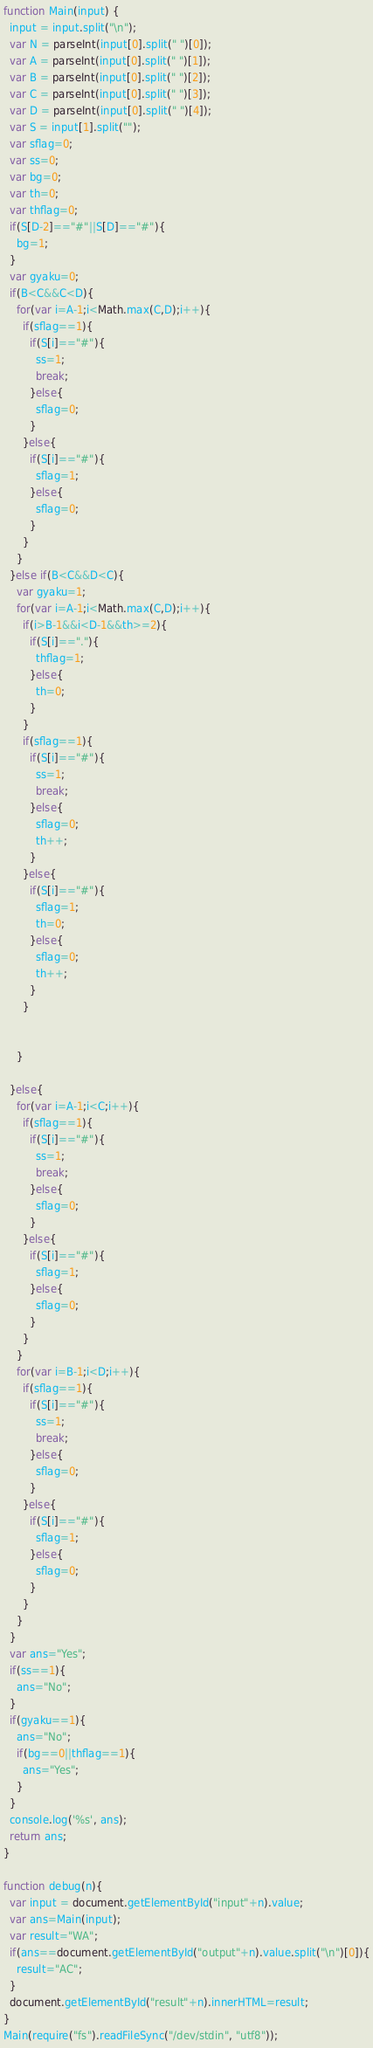<code> <loc_0><loc_0><loc_500><loc_500><_JavaScript_>

function Main(input) {
  input = input.split("\n");
  var N = parseInt(input[0].split(" ")[0]);
  var A = parseInt(input[0].split(" ")[1]);
  var B = parseInt(input[0].split(" ")[2]);
  var C = parseInt(input[0].split(" ")[3]);
  var D = parseInt(input[0].split(" ")[4]);
  var S = input[1].split("");
  var sflag=0;
  var ss=0;
  var bg=0;
  var th=0;
  var thflag=0;
  if(S[D-2]=="#"||S[D]=="#"){
    bg=1;
  }
  var gyaku=0;
  if(B<C&&C<D){
    for(var i=A-1;i<Math.max(C,D);i++){
      if(sflag==1){
        if(S[i]=="#"){
          ss=1;
          break;
        }else{
          sflag=0;
        }
      }else{
        if(S[i]=="#"){
          sflag=1;
        }else{
          sflag=0;
        }
      }
    }
  }else if(B<C&&D<C){
    var gyaku=1;
    for(var i=A-1;i<Math.max(C,D);i++){
      if(i>B-1&&i<D-1&&th>=2){
        if(S[i]=="."){
          thflag=1;
        }else{
          th=0;
        }
      }
      if(sflag==1){
        if(S[i]=="#"){
          ss=1;
          break;
        }else{
          sflag=0;
          th++;
        }
      }else{
        if(S[i]=="#"){
          sflag=1;
          th=0;
        }else{
          sflag=0;
          th++;
        }
      }


    }

  }else{
    for(var i=A-1;i<C;i++){
      if(sflag==1){
        if(S[i]=="#"){
          ss=1;
          break;
        }else{
          sflag=0;
        }
      }else{
        if(S[i]=="#"){
          sflag=1;
        }else{
          sflag=0;
        }
      }
    }
    for(var i=B-1;i<D;i++){
      if(sflag==1){
        if(S[i]=="#"){
          ss=1;
          break;
        }else{
          sflag=0;
        }
      }else{
        if(S[i]=="#"){
          sflag=1;
        }else{
          sflag=0;
        }
      }
    }
  }
  var ans="Yes";
  if(ss==1){
    ans="No";
  }
  if(gyaku==1){
    ans="No";
    if(bg==0||thflag==1){
      ans="Yes";
    }
  }
  console.log('%s', ans);
  return ans;
}

function debug(n){
  var input = document.getElementById("input"+n).value;
  var ans=Main(input);
  var result="WA";
  if(ans==document.getElementById("output"+n).value.split("\n")[0]){
    result="AC";
  }
  document.getElementById("result"+n).innerHTML=result;
}
Main(require("fs").readFileSync("/dev/stdin", "utf8"));</code> 